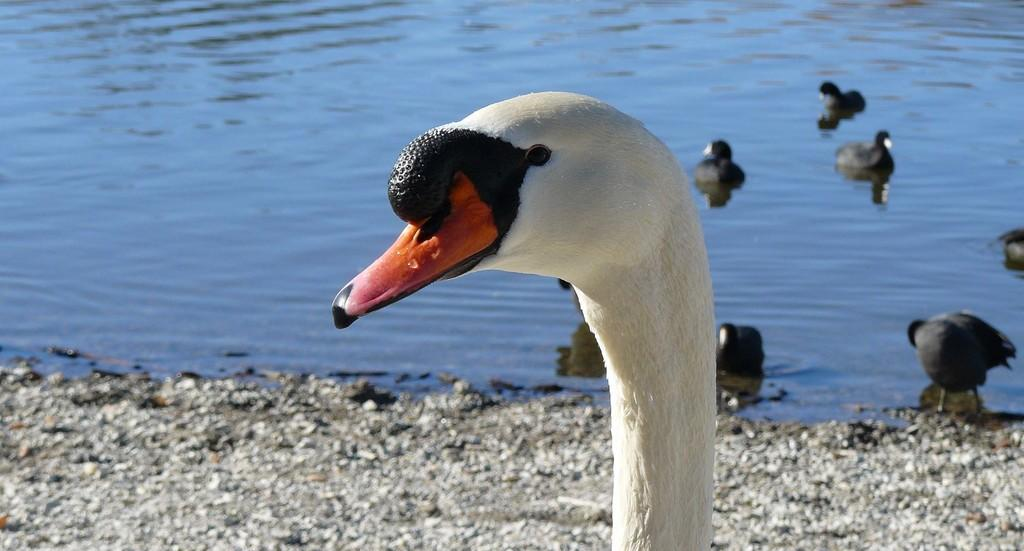What is the main subject in the center of the image? There is a swan in the center of the image. What other animals can be seen in the image? There are ducks in the background of the image. Where are the ducks located? The ducks are on the water in the background. What can be seen at the bottom of the image? There are stones at the bottom of the image. What type of tray is being used to hold the sheep in the image? There are no sheep or trays present in the image. 